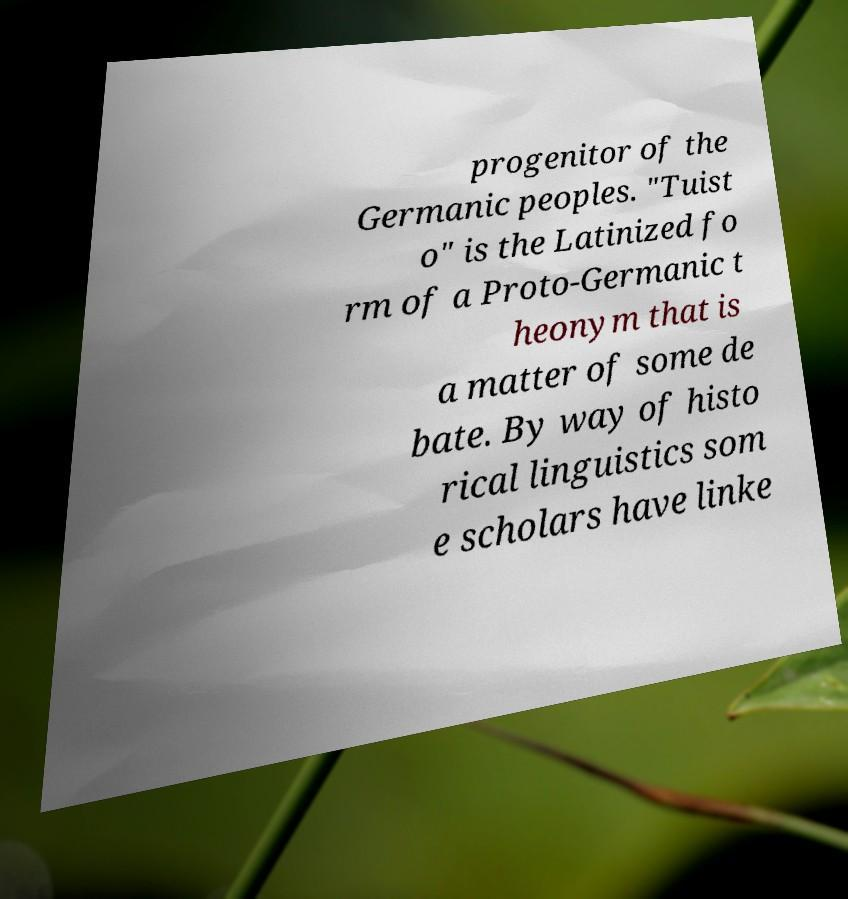I need the written content from this picture converted into text. Can you do that? progenitor of the Germanic peoples. "Tuist o" is the Latinized fo rm of a Proto-Germanic t heonym that is a matter of some de bate. By way of histo rical linguistics som e scholars have linke 